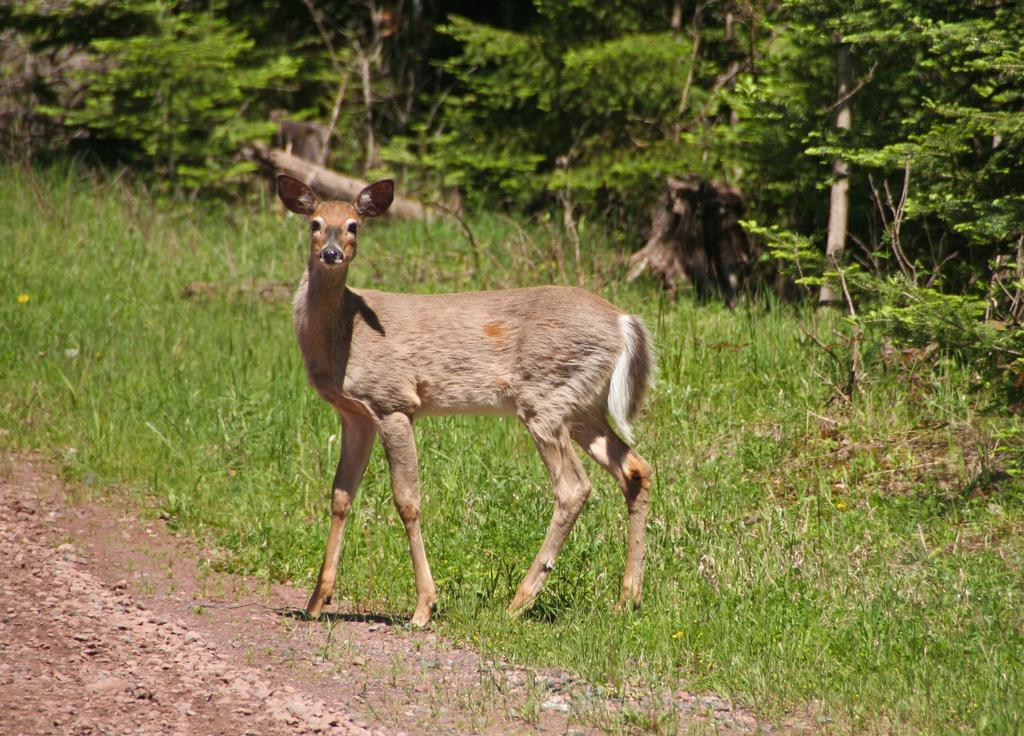Where was the picture taken? The picture was clicked outside the city. What is the main subject in the center of the image? There is an animal standing on the ground in the center of the image. What type of vegetation can be seen in the image? There is green grass, plants, and trees visible in the image. What type of toy can be seen in the hands of the animal in the image? There is no toy present in the image; it features an animal standing on the ground in a natural environment. What kind of noise does the animal make in the image? The image is a still picture and does not capture any sounds, so it is impossible to determine the noise made by the animal. 